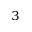<formula> <loc_0><loc_0><loc_500><loc_500>^ { 3 }</formula> 